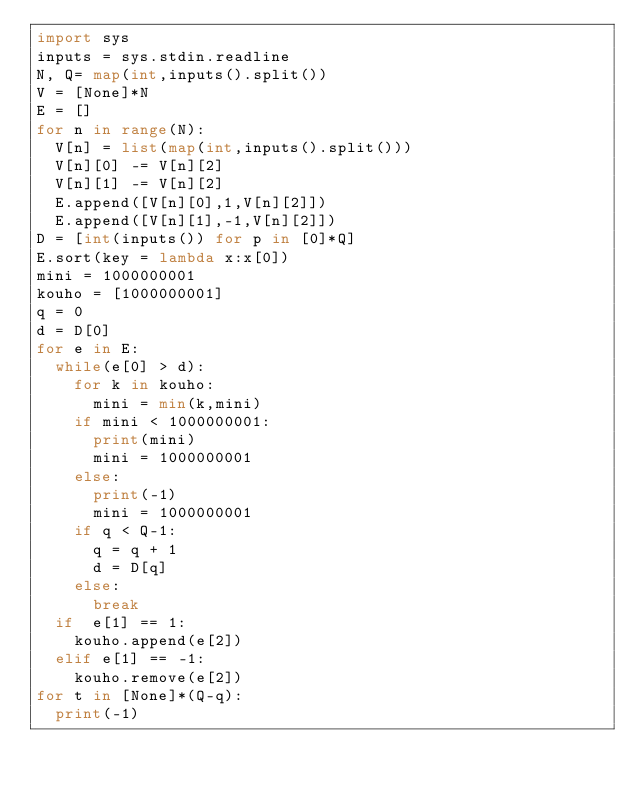<code> <loc_0><loc_0><loc_500><loc_500><_Python_>import sys
inputs = sys.stdin.readline
N, Q= map(int,inputs().split())
V = [None]*N
E = []
for n in range(N):
	V[n] = list(map(int,inputs().split()))
	V[n][0] -= V[n][2]
	V[n][1] -= V[n][2]
	E.append([V[n][0],1,V[n][2]])
	E.append([V[n][1],-1,V[n][2]])
D = [int(inputs()) for p in [0]*Q]
E.sort(key = lambda x:x[0])
mini = 1000000001
kouho = [1000000001]
q = 0
d = D[0]
for e in E:
	while(e[0] > d):
		for k in kouho:
			mini = min(k,mini)
		if mini < 1000000001:
			print(mini)
			mini = 1000000001
		else:
			print(-1)
			mini = 1000000001
		if q < Q-1:
			q = q + 1
			d = D[q]
		else:
			break
	if  e[1] == 1:
		kouho.append(e[2])
	elif e[1] == -1:
		kouho.remove(e[2])
for t in [None]*(Q-q):
	print(-1)</code> 